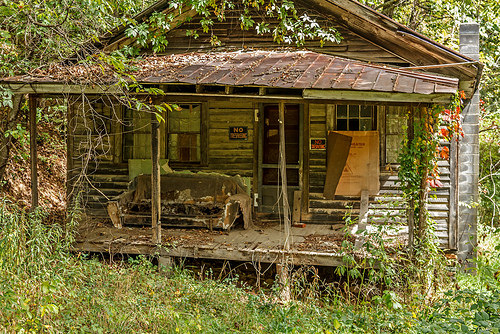<image>
Is there a couch on the porch? Yes. Looking at the image, I can see the couch is positioned on top of the porch, with the porch providing support. Is there a cardboard in front of the window? Yes. The cardboard is positioned in front of the window, appearing closer to the camera viewpoint. 